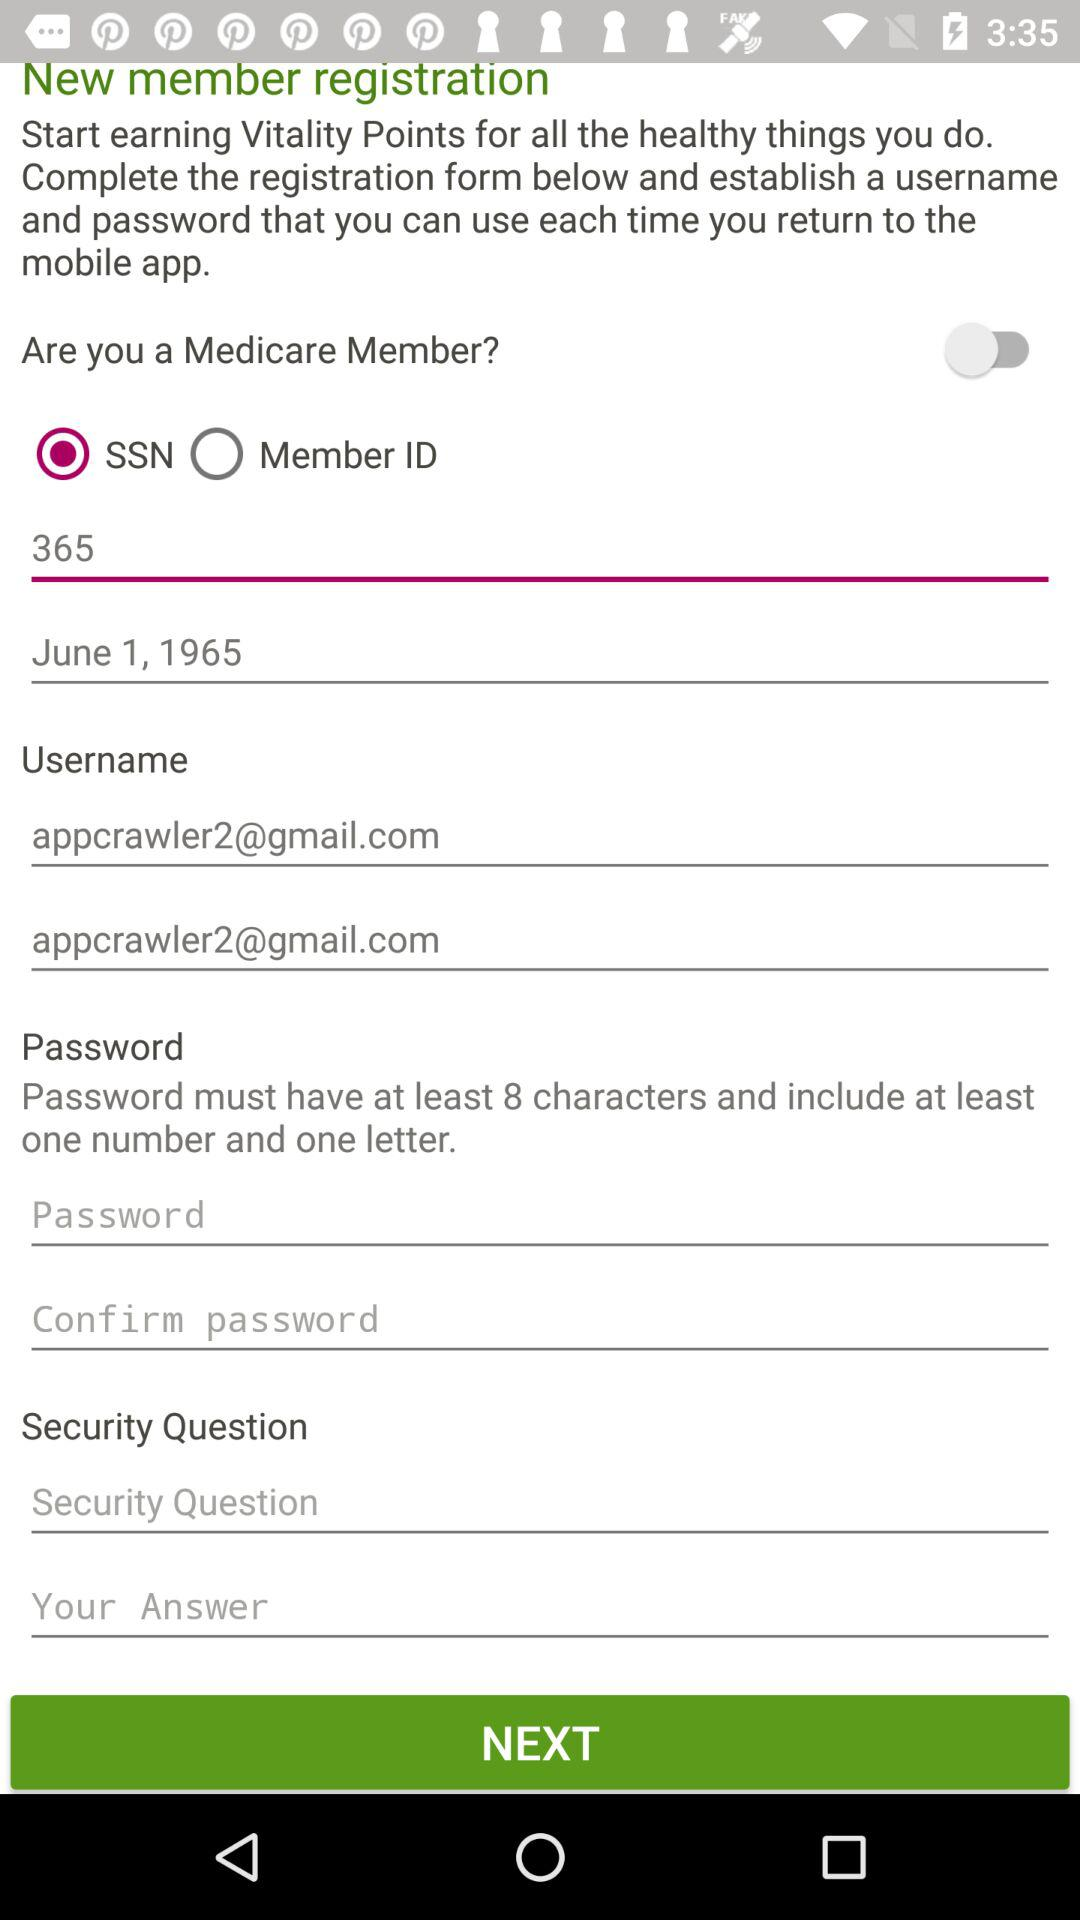What is the email address of the user? The email address of the user is appcrawler2@gmail.com. 